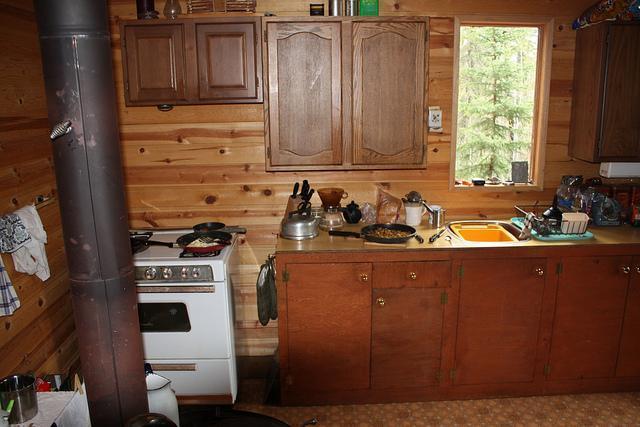How many towels are shown?
Give a very brief answer. 3. 